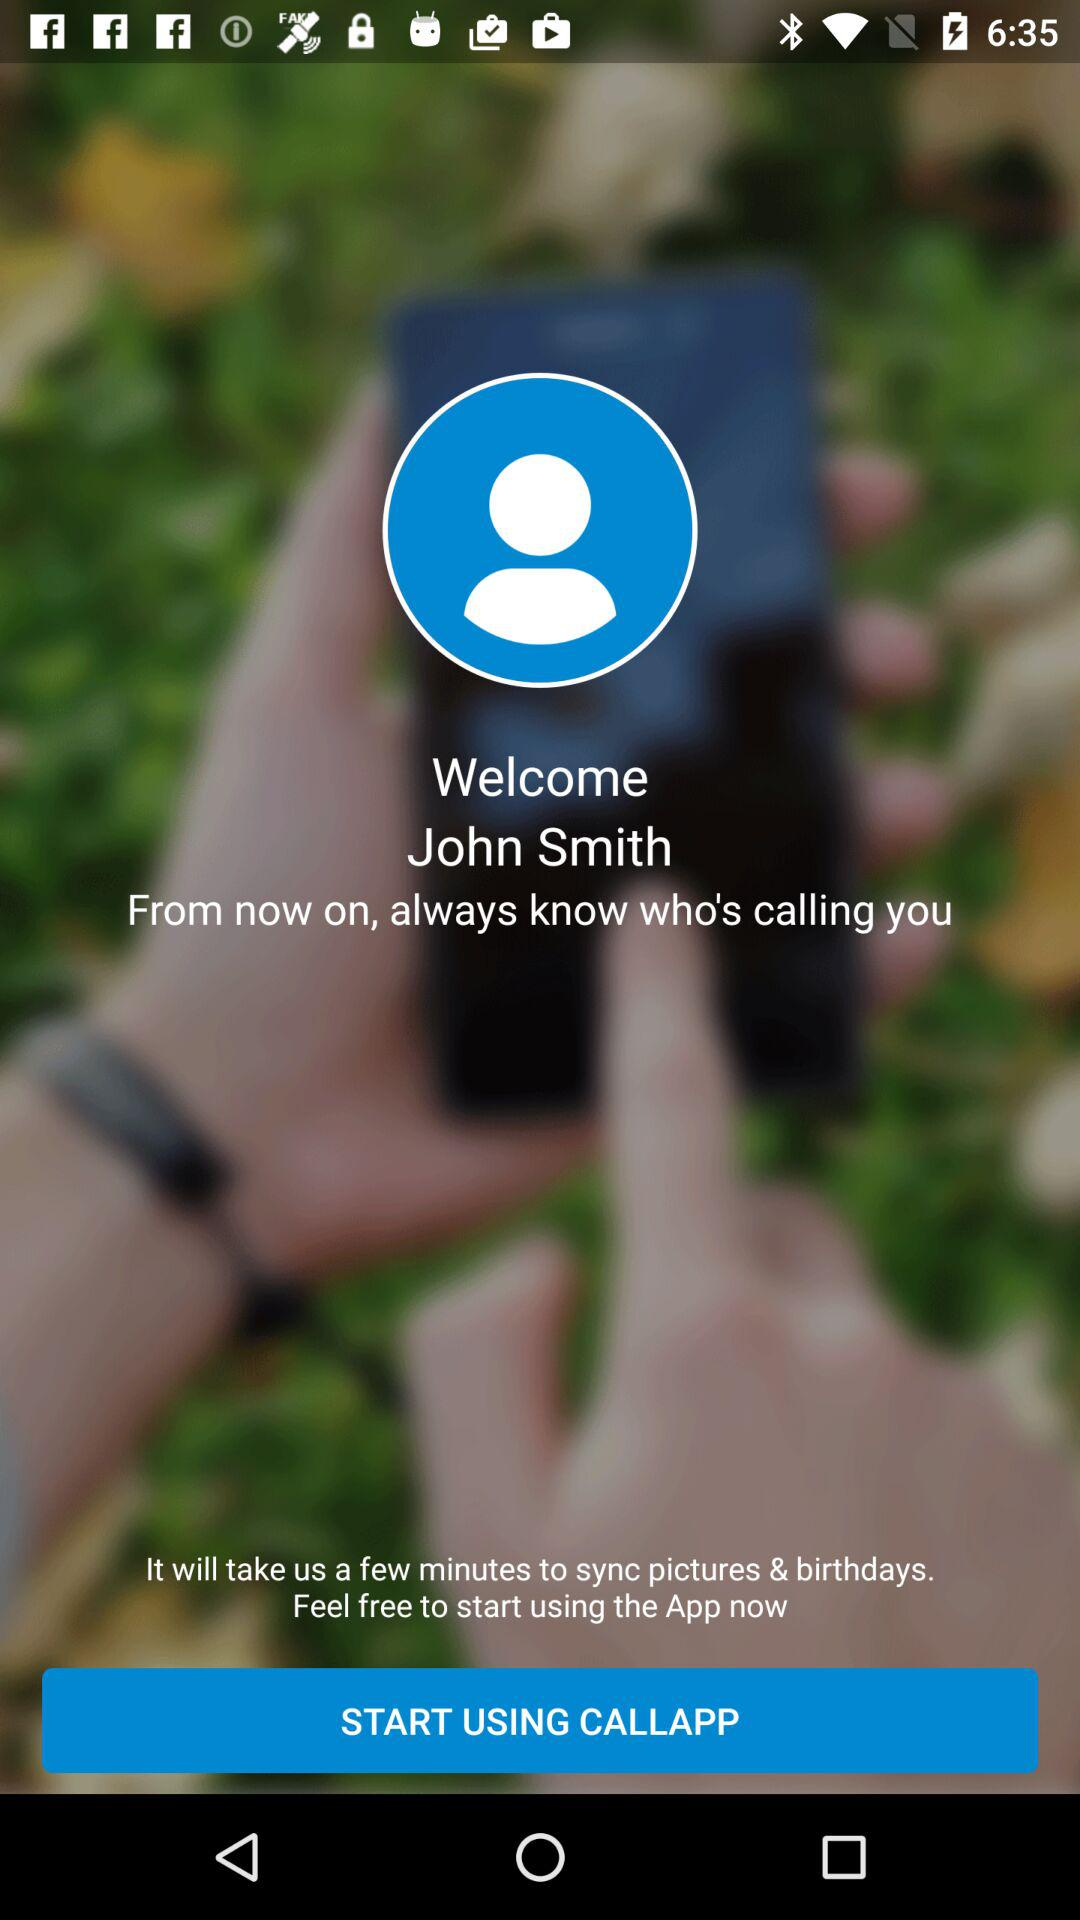Who are John Smith's contacts?
When the provided information is insufficient, respond with <no answer>. <no answer> 